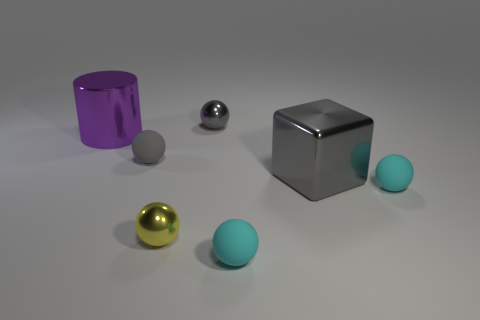Add 1 tiny gray spheres. How many objects exist? 8 Subtract all small gray spheres. How many spheres are left? 3 Subtract all red spheres. Subtract all red blocks. How many spheres are left? 5 Subtract all red cylinders. How many yellow spheres are left? 1 Subtract all small metallic spheres. Subtract all tiny cyan spheres. How many objects are left? 3 Add 3 small yellow metallic spheres. How many small yellow metallic spheres are left? 4 Add 1 gray balls. How many gray balls exist? 3 Subtract all yellow spheres. How many spheres are left? 4 Subtract 0 green blocks. How many objects are left? 7 Subtract all balls. How many objects are left? 2 